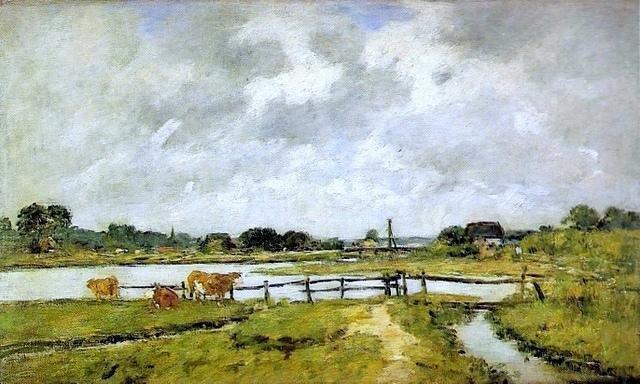How many animals is in this painting?
Give a very brief answer. 3. How many of the boys are wearing a hat?
Give a very brief answer. 0. 